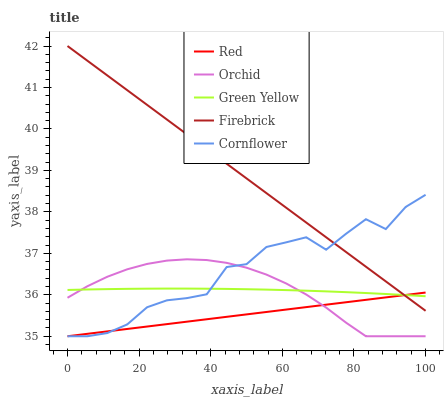Does Red have the minimum area under the curve?
Answer yes or no. Yes. Does Firebrick have the maximum area under the curve?
Answer yes or no. Yes. Does Green Yellow have the minimum area under the curve?
Answer yes or no. No. Does Green Yellow have the maximum area under the curve?
Answer yes or no. No. Is Firebrick the smoothest?
Answer yes or no. Yes. Is Cornflower the roughest?
Answer yes or no. Yes. Is Green Yellow the smoothest?
Answer yes or no. No. Is Green Yellow the roughest?
Answer yes or no. No. Does Cornflower have the lowest value?
Answer yes or no. Yes. Does Firebrick have the lowest value?
Answer yes or no. No. Does Firebrick have the highest value?
Answer yes or no. Yes. Does Green Yellow have the highest value?
Answer yes or no. No. Is Orchid less than Firebrick?
Answer yes or no. Yes. Is Firebrick greater than Orchid?
Answer yes or no. Yes. Does Red intersect Cornflower?
Answer yes or no. Yes. Is Red less than Cornflower?
Answer yes or no. No. Is Red greater than Cornflower?
Answer yes or no. No. Does Orchid intersect Firebrick?
Answer yes or no. No. 